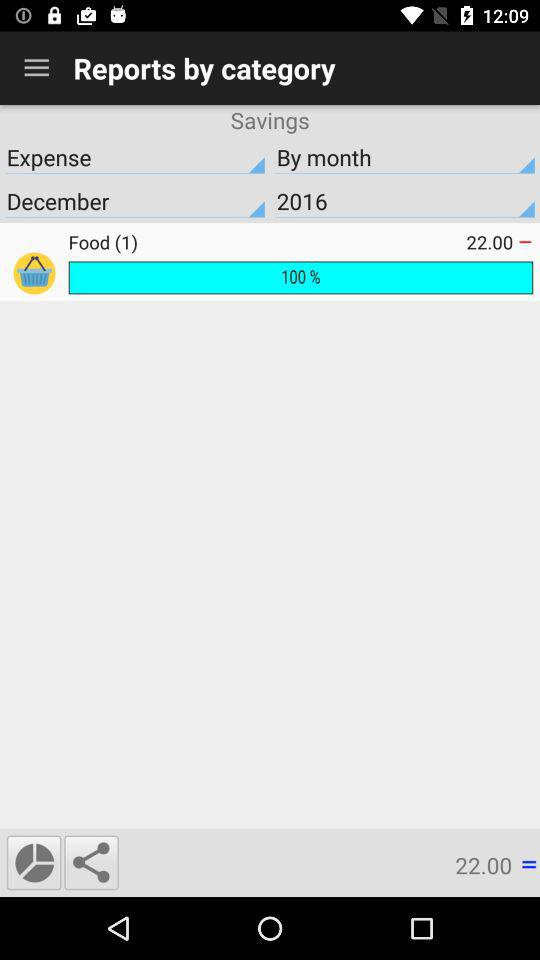What is the selected year? The selected year is 2016. 